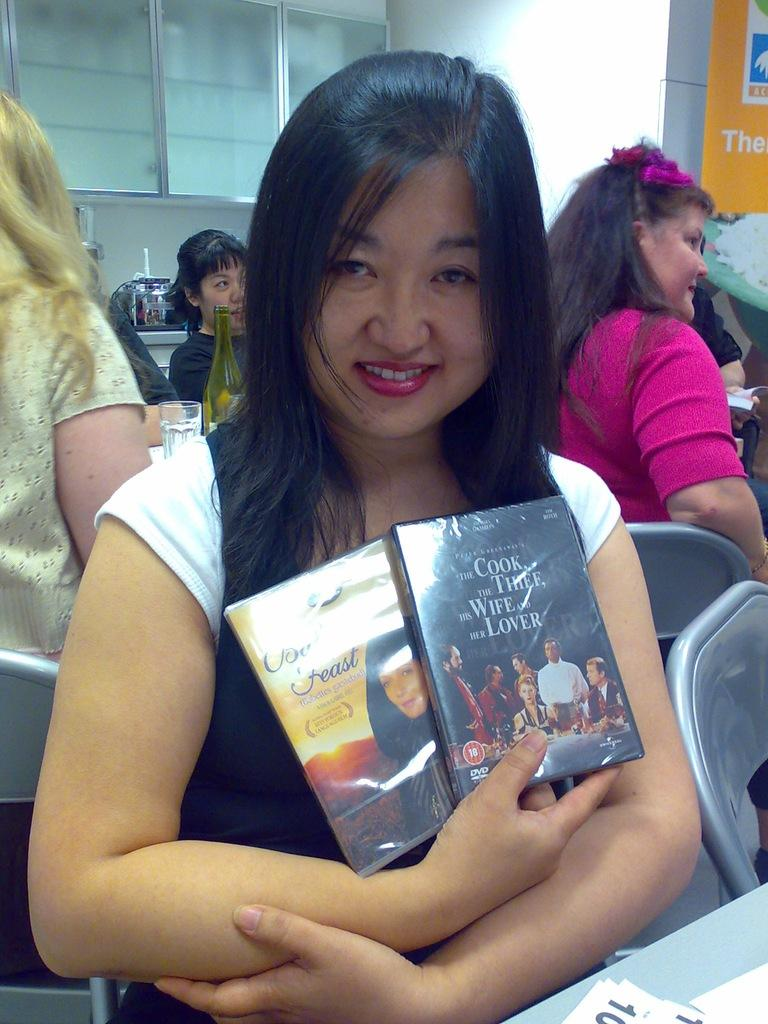<image>
Offer a succinct explanation of the picture presented. A women holding two books with one titled The Cook, The Thief, His Wife And Her Lover. 